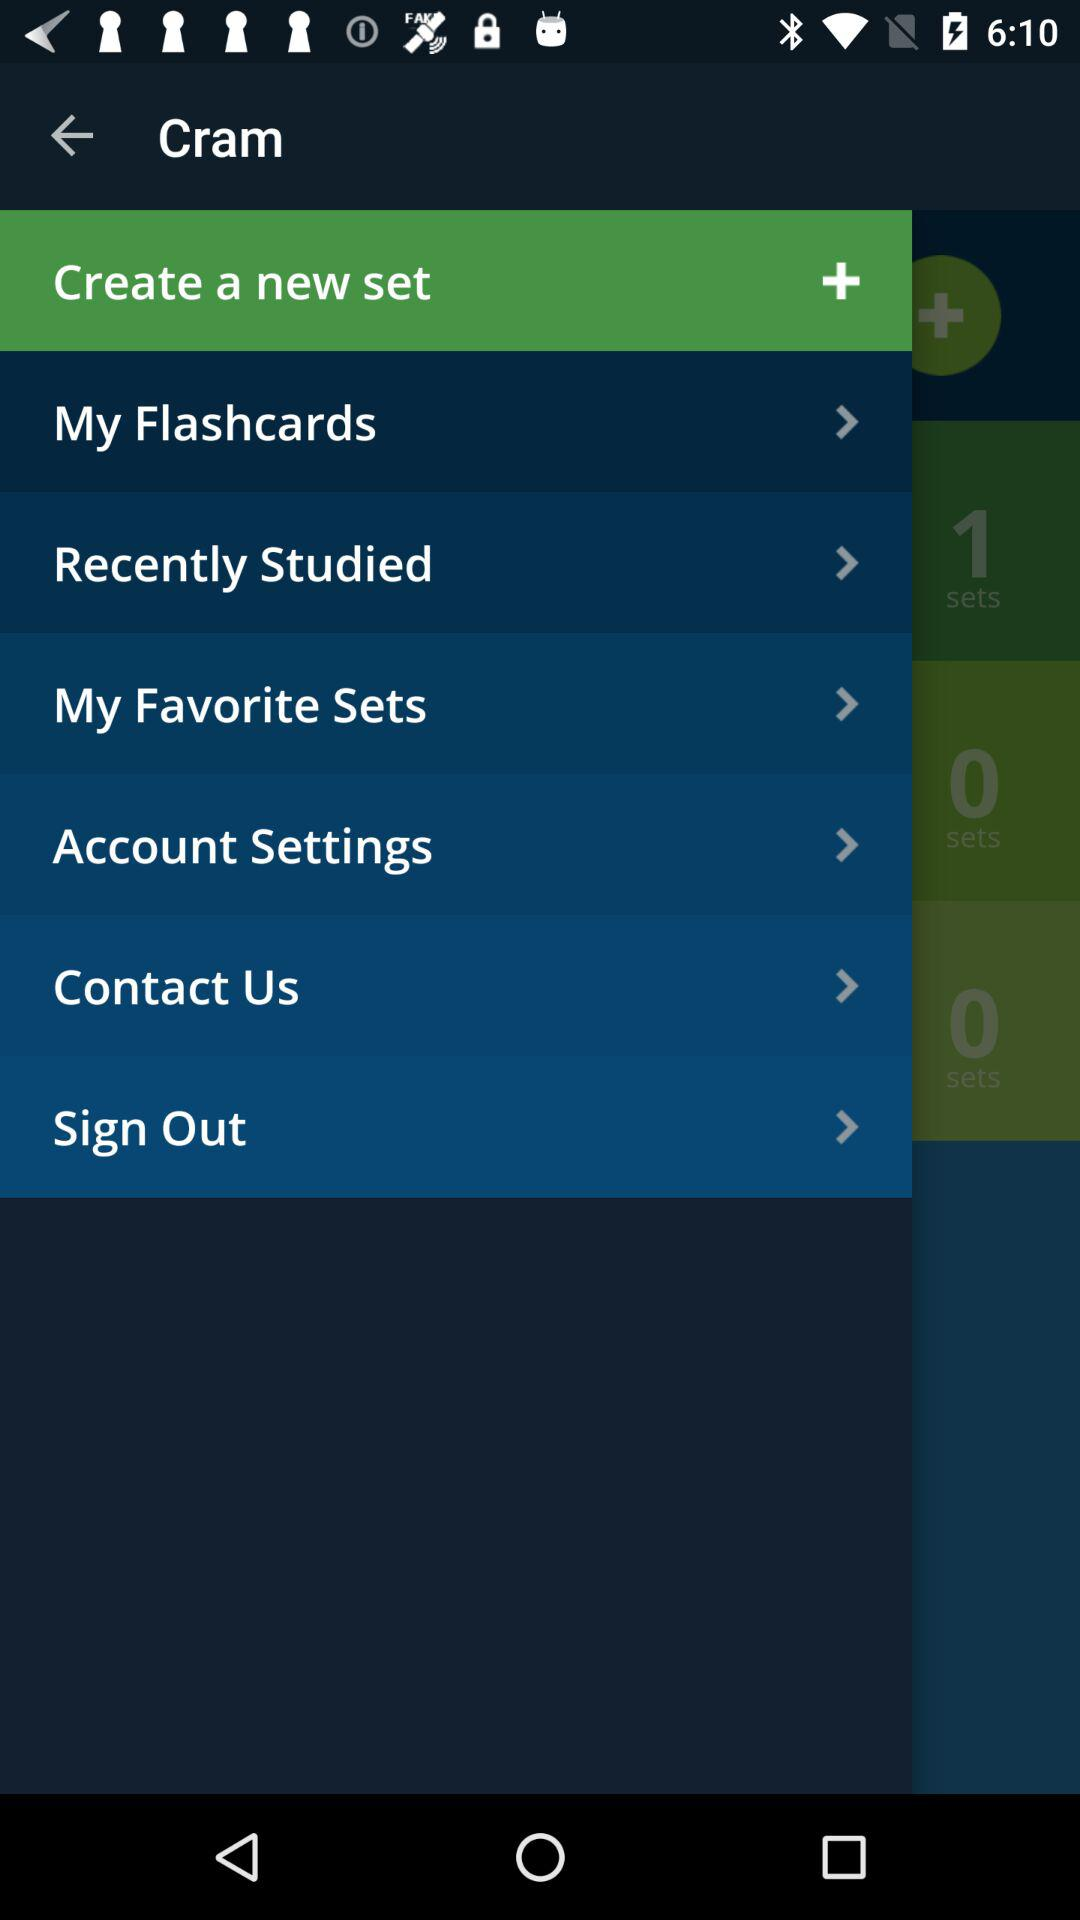Which option is selected? The selected option is "Create a new set". 